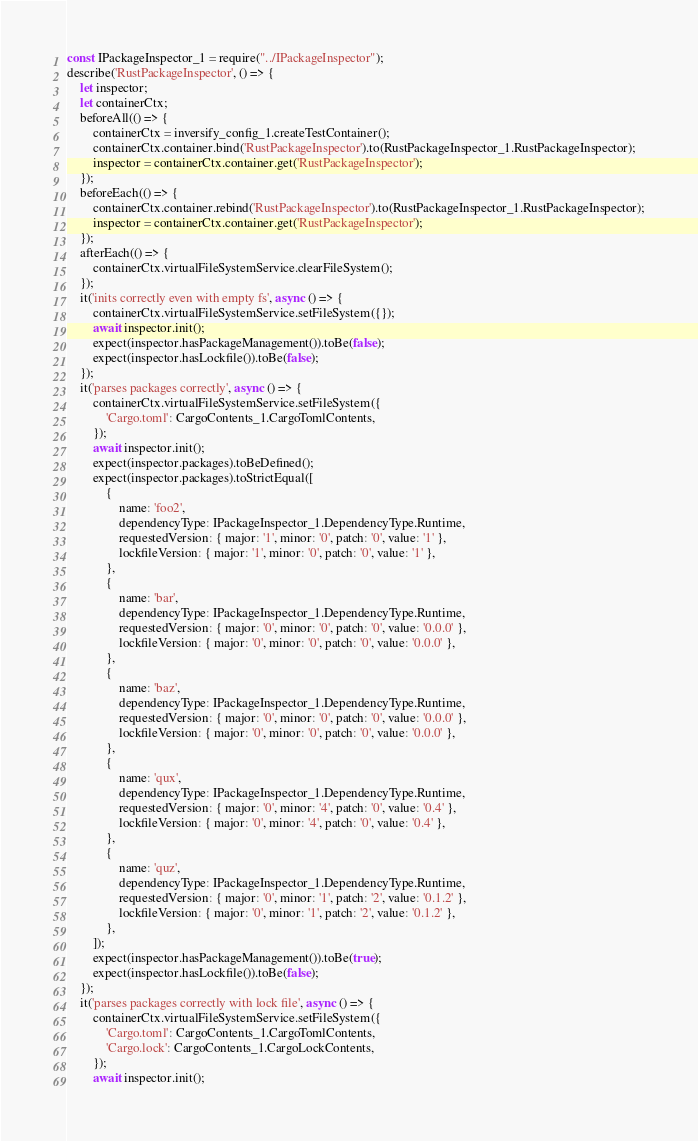Convert code to text. <code><loc_0><loc_0><loc_500><loc_500><_JavaScript_>const IPackageInspector_1 = require("../IPackageInspector");
describe('RustPackageInspector', () => {
    let inspector;
    let containerCtx;
    beforeAll(() => {
        containerCtx = inversify_config_1.createTestContainer();
        containerCtx.container.bind('RustPackageInspector').to(RustPackageInspector_1.RustPackageInspector);
        inspector = containerCtx.container.get('RustPackageInspector');
    });
    beforeEach(() => {
        containerCtx.container.rebind('RustPackageInspector').to(RustPackageInspector_1.RustPackageInspector);
        inspector = containerCtx.container.get('RustPackageInspector');
    });
    afterEach(() => {
        containerCtx.virtualFileSystemService.clearFileSystem();
    });
    it('inits correctly even with empty fs', async () => {
        containerCtx.virtualFileSystemService.setFileSystem({});
        await inspector.init();
        expect(inspector.hasPackageManagement()).toBe(false);
        expect(inspector.hasLockfile()).toBe(false);
    });
    it('parses packages correctly', async () => {
        containerCtx.virtualFileSystemService.setFileSystem({
            'Cargo.toml': CargoContents_1.CargoTomlContents,
        });
        await inspector.init();
        expect(inspector.packages).toBeDefined();
        expect(inspector.packages).toStrictEqual([
            {
                name: 'foo2',
                dependencyType: IPackageInspector_1.DependencyType.Runtime,
                requestedVersion: { major: '1', minor: '0', patch: '0', value: '1' },
                lockfileVersion: { major: '1', minor: '0', patch: '0', value: '1' },
            },
            {
                name: 'bar',
                dependencyType: IPackageInspector_1.DependencyType.Runtime,
                requestedVersion: { major: '0', minor: '0', patch: '0', value: '0.0.0' },
                lockfileVersion: { major: '0', minor: '0', patch: '0', value: '0.0.0' },
            },
            {
                name: 'baz',
                dependencyType: IPackageInspector_1.DependencyType.Runtime,
                requestedVersion: { major: '0', minor: '0', patch: '0', value: '0.0.0' },
                lockfileVersion: { major: '0', minor: '0', patch: '0', value: '0.0.0' },
            },
            {
                name: 'qux',
                dependencyType: IPackageInspector_1.DependencyType.Runtime,
                requestedVersion: { major: '0', minor: '4', patch: '0', value: '0.4' },
                lockfileVersion: { major: '0', minor: '4', patch: '0', value: '0.4' },
            },
            {
                name: 'quz',
                dependencyType: IPackageInspector_1.DependencyType.Runtime,
                requestedVersion: { major: '0', minor: '1', patch: '2', value: '0.1.2' },
                lockfileVersion: { major: '0', minor: '1', patch: '2', value: '0.1.2' },
            },
        ]);
        expect(inspector.hasPackageManagement()).toBe(true);
        expect(inspector.hasLockfile()).toBe(false);
    });
    it('parses packages correctly with lock file', async () => {
        containerCtx.virtualFileSystemService.setFileSystem({
            'Cargo.toml': CargoContents_1.CargoTomlContents,
            'Cargo.lock': CargoContents_1.CargoLockContents,
        });
        await inspector.init();</code> 